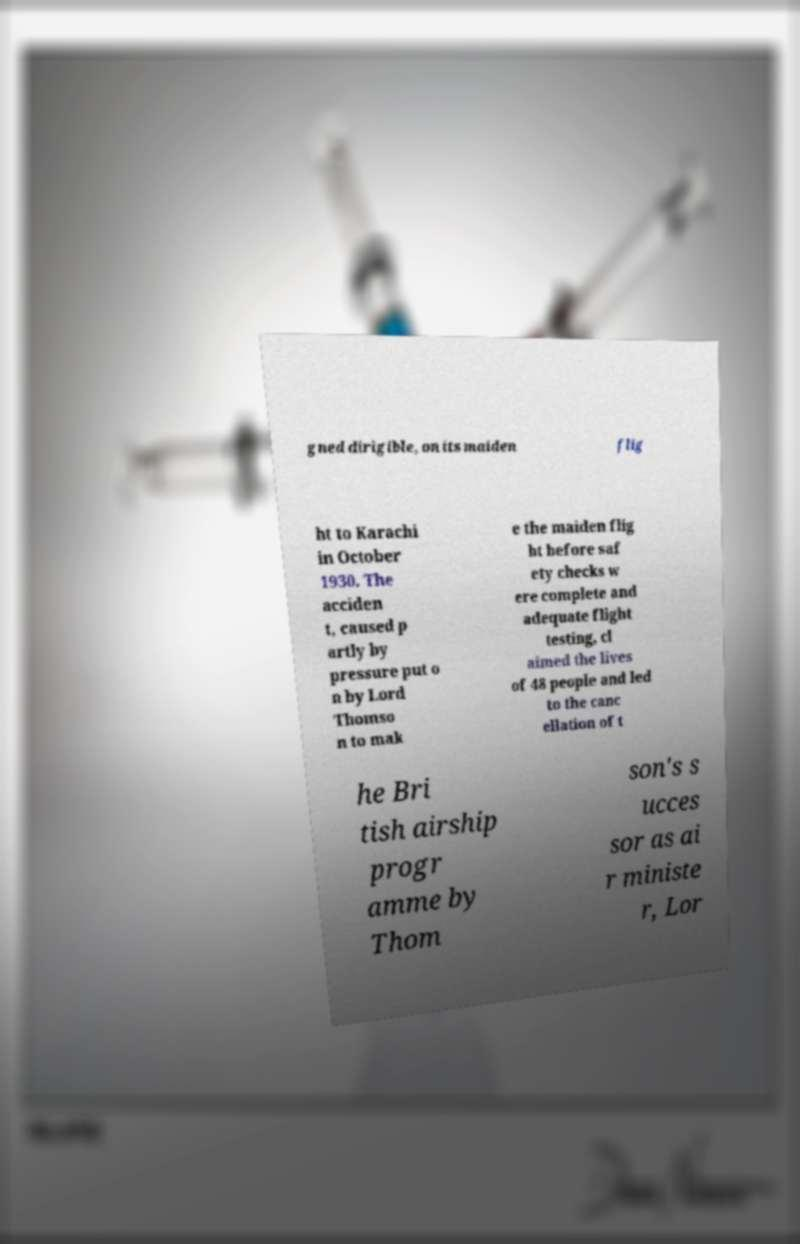Could you assist in decoding the text presented in this image and type it out clearly? gned dirigible, on its maiden flig ht to Karachi in October 1930. The acciden t, caused p artly by pressure put o n by Lord Thomso n to mak e the maiden flig ht before saf ety checks w ere complete and adequate flight testing, cl aimed the lives of 48 people and led to the canc ellation of t he Bri tish airship progr amme by Thom son's s ucces sor as ai r ministe r, Lor 